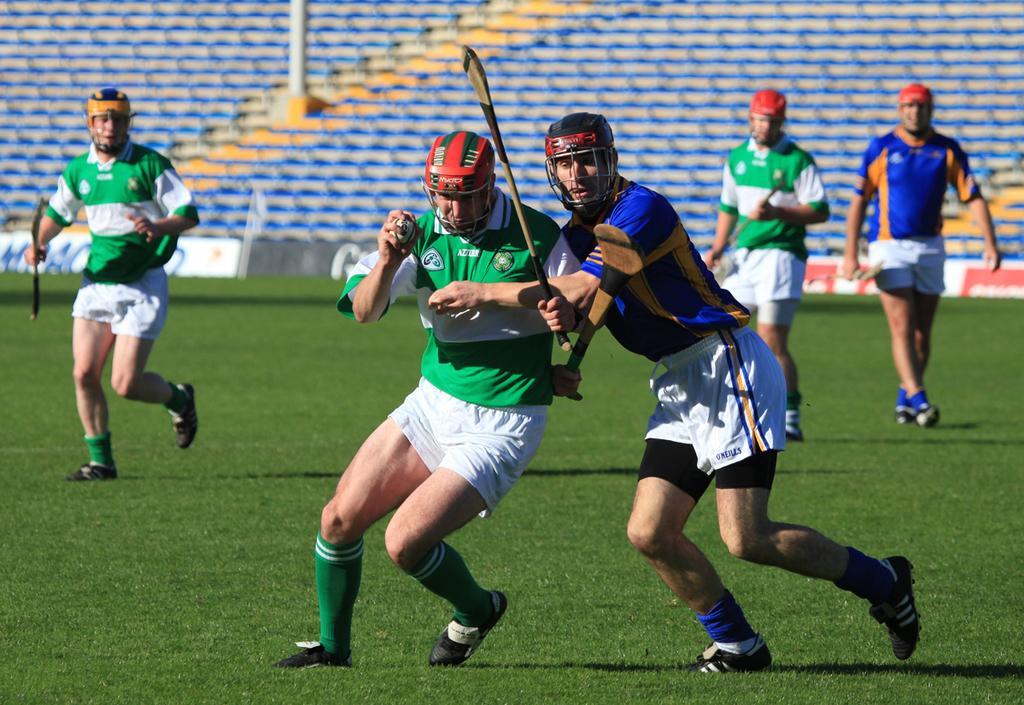Could you give a brief overview of what you see in this image? In this image there are men holding an object, there is a playground, there are boards, there is text on the boards, there are cars, there is a pole towards the top of the image. 